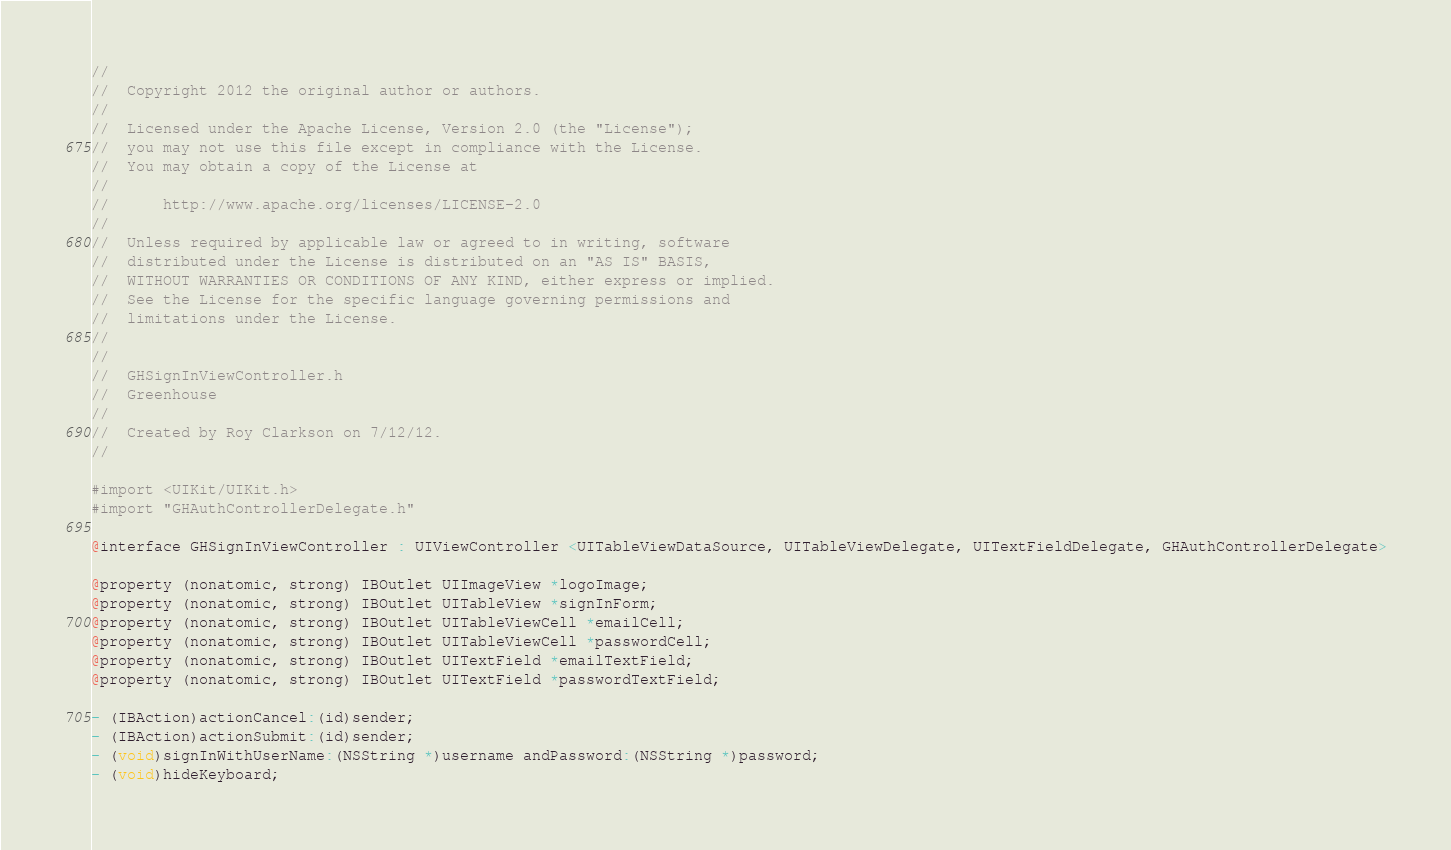<code> <loc_0><loc_0><loc_500><loc_500><_C_>//
//  Copyright 2012 the original author or authors.
//
//  Licensed under the Apache License, Version 2.0 (the "License");
//  you may not use this file except in compliance with the License.
//  You may obtain a copy of the License at
//
//      http://www.apache.org/licenses/LICENSE-2.0
//
//  Unless required by applicable law or agreed to in writing, software
//  distributed under the License is distributed on an "AS IS" BASIS,
//  WITHOUT WARRANTIES OR CONDITIONS OF ANY KIND, either express or implied.
//  See the License for the specific language governing permissions and
//  limitations under the License.
//
//
//  GHSignInViewController.h
//  Greenhouse
//
//  Created by Roy Clarkson on 7/12/12.
//

#import <UIKit/UIKit.h>
#import "GHAuthControllerDelegate.h"

@interface GHSignInViewController : UIViewController <UITableViewDataSource, UITableViewDelegate, UITextFieldDelegate, GHAuthControllerDelegate>

@property (nonatomic, strong) IBOutlet UIImageView *logoImage;
@property (nonatomic, strong) IBOutlet UITableView *signInForm;
@property (nonatomic, strong) IBOutlet UITableViewCell *emailCell;
@property (nonatomic, strong) IBOutlet UITableViewCell *passwordCell;
@property (nonatomic, strong) IBOutlet UITextField *emailTextField;
@property (nonatomic, strong) IBOutlet UITextField *passwordTextField;

- (IBAction)actionCancel:(id)sender;
- (IBAction)actionSubmit:(id)sender;
- (void)signInWithUserName:(NSString *)username andPassword:(NSString *)password;
- (void)hideKeyboard;</code> 